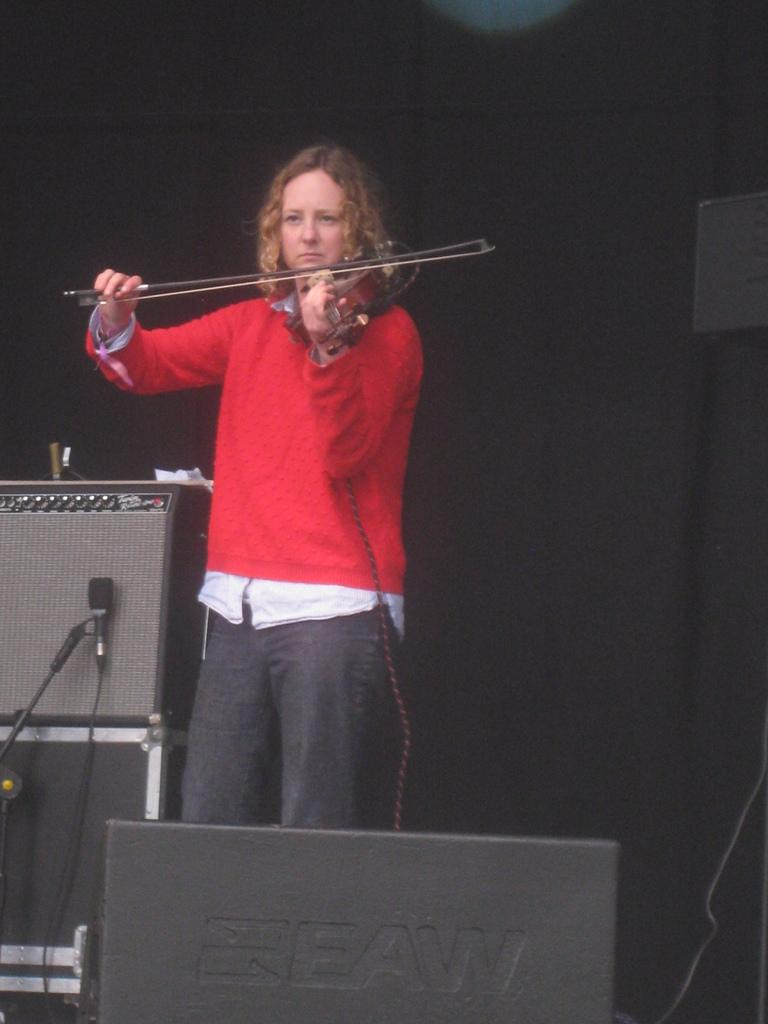Who is the main subject in the image? There is a woman in the image. What is the woman wearing? The woman is wearing a red t-shirt. What is the woman doing in the image? The woman is playing a violin with a stick. What objects are present in the image related to sound? There is a speaker and a microphone with a holder in the image. What type of tree can be seen in the background of the image? There is no tree visible in the image. What book is the woman reading in the image? The woman is not reading a book in the image; she is playing a violin with a stick. 